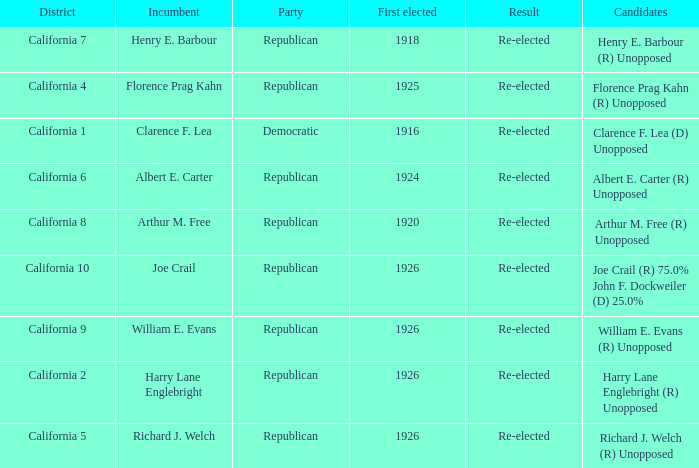 how many candidates with district being california 7 1.0. 